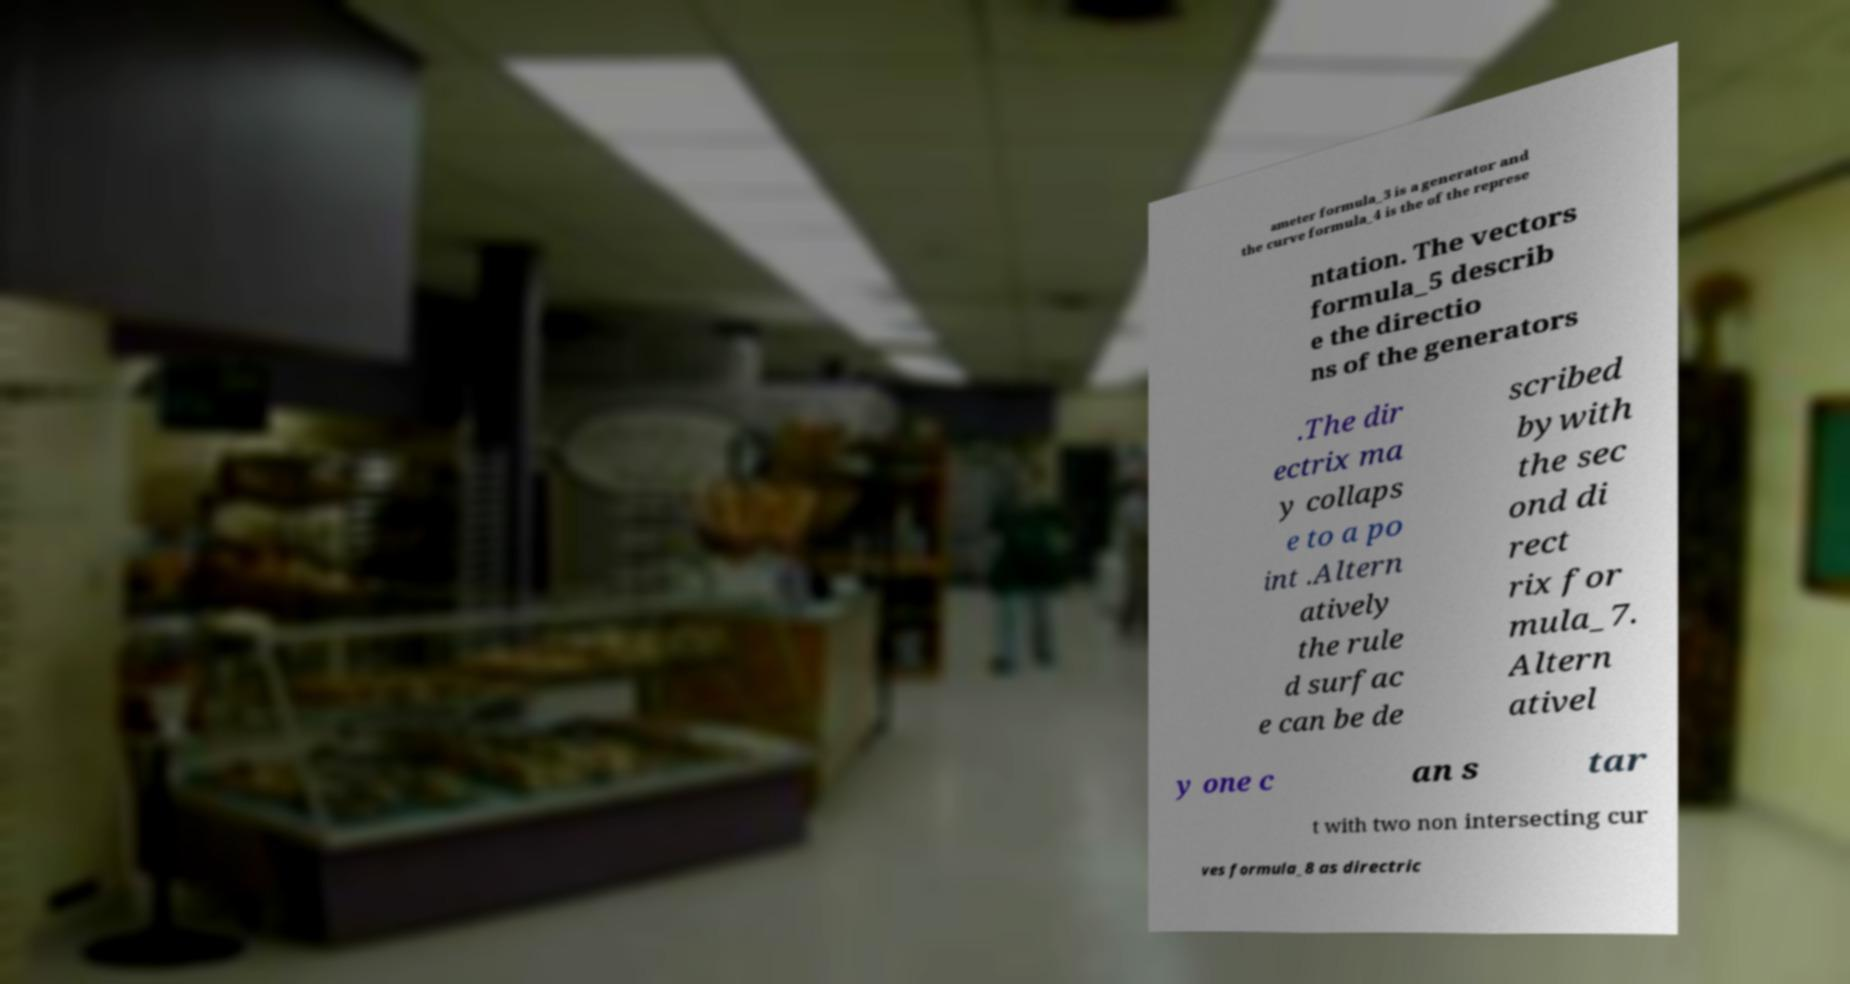Please identify and transcribe the text found in this image. ameter formula_3 is a generator and the curve formula_4 is the of the represe ntation. The vectors formula_5 describ e the directio ns of the generators .The dir ectrix ma y collaps e to a po int .Altern atively the rule d surfac e can be de scribed bywith the sec ond di rect rix for mula_7. Altern ativel y one c an s tar t with two non intersecting cur ves formula_8 as directric 